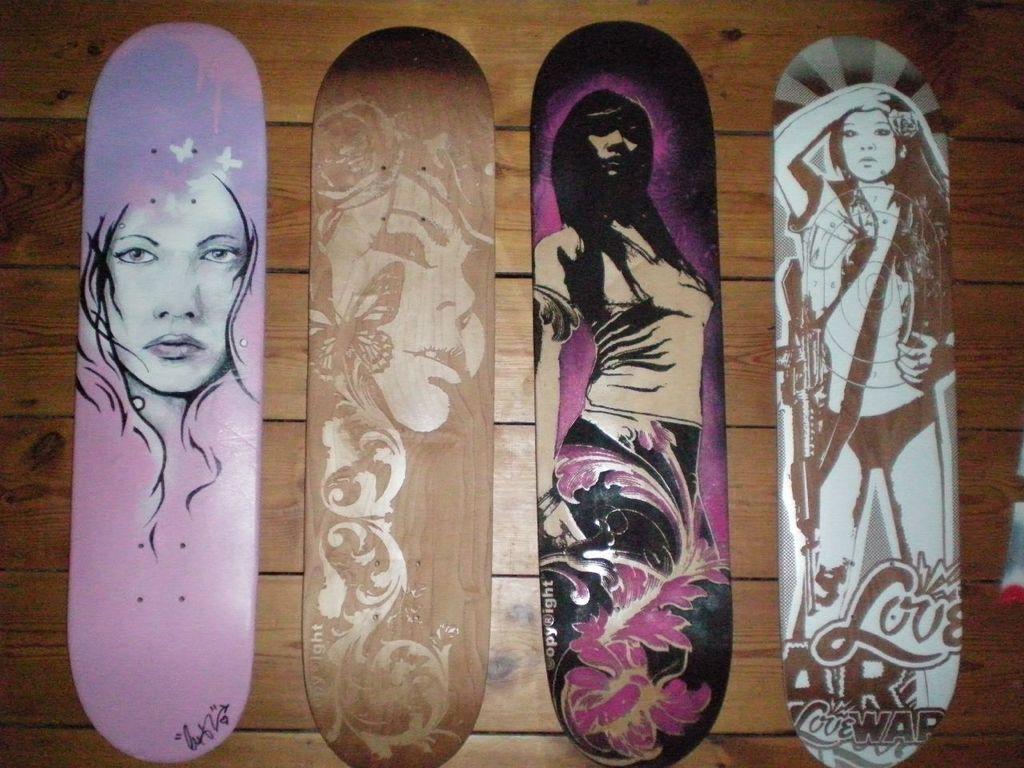Please provide a concise description of this image. This image consists of four skateboards kept on the floor. The floor is made of wood. 